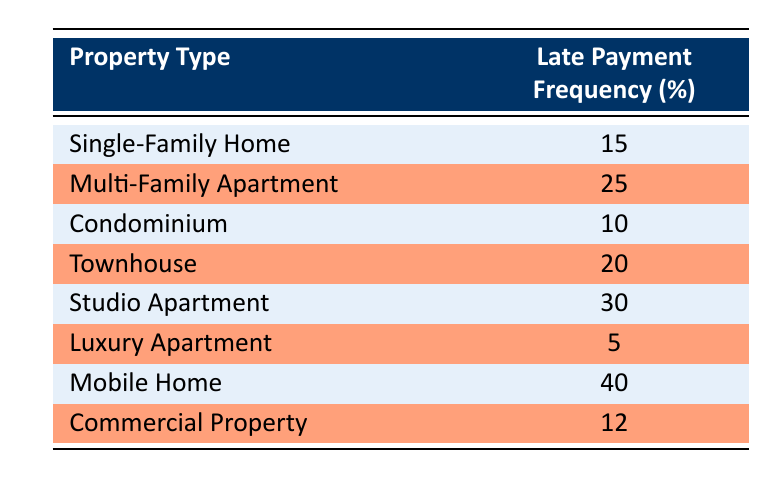What is the late payment frequency for Mobile Homes? The table lists the late payment frequency for each property type, and for Mobile Homes, it is specified as 40.
Answer: 40 Which property type has the highest late payment frequency? By reviewing the table, Mobile Homes have the highest late payment frequency at 40, which is greater than any other property type listed.
Answer: Mobile Home What is the total late payment frequency for Townhouses and Multi-Family Apartments combined? The late payment frequency for Townhouses is 20 and for Multi-Family Apartments is 25. Adding these together, 20 + 25 gives a total of 45.
Answer: 45 Is the late payment frequency for Luxury Apartments higher than for Condominiums? Luxury Apartments have a late payment frequency of 5, while Condominiums have 10. Since 5 is not greater than 10, the statement is false.
Answer: No What is the average late payment frequency for all property types listed? To find the average, sum all the late payment frequencies like this: 15 + 25 + 10 + 20 + 30 + 5 + 40 + 12 = 157. There are 8 property types, so the average is 157/8 = 19.625.
Answer: 19.625 How many property types have a late payment frequency of 20 or higher? From the table, we can see that the property types with a late payment frequency of 20 or higher are Multi-Family Apartments, Townhouses, Studio Apartments, and Mobile Homes, amounting to 4 property types.
Answer: 4 What is the difference between the highest and lowest late payment frequencies? The highest frequency is 40 (Mobile Homes) and the lowest frequency is 5 (Luxury Apartments). The difference between them is 40 - 5 = 35.
Answer: 35 Are the late payments for Single-Family Homes greater than 10? The late payment frequency for Single-Family Homes is noted as 15, which is indeed greater than 10, making the statement true.
Answer: Yes What property type has the second highest late payment frequency? The property type with the highest frequency is Mobile Homes at 40, and the next is Studio Apartments at 30, as no other types exceed that frequency.
Answer: Studio Apartment 